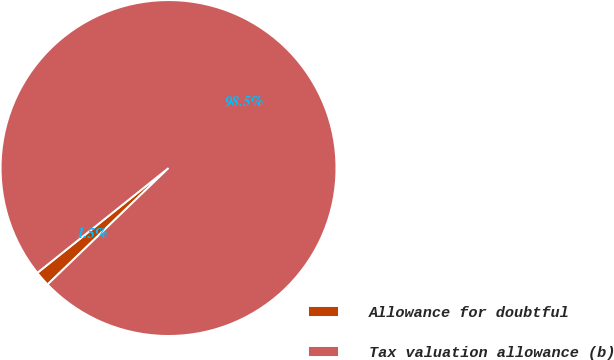Convert chart to OTSL. <chart><loc_0><loc_0><loc_500><loc_500><pie_chart><fcel>Allowance for doubtful<fcel>Tax valuation allowance (b)<nl><fcel>1.47%<fcel>98.53%<nl></chart> 